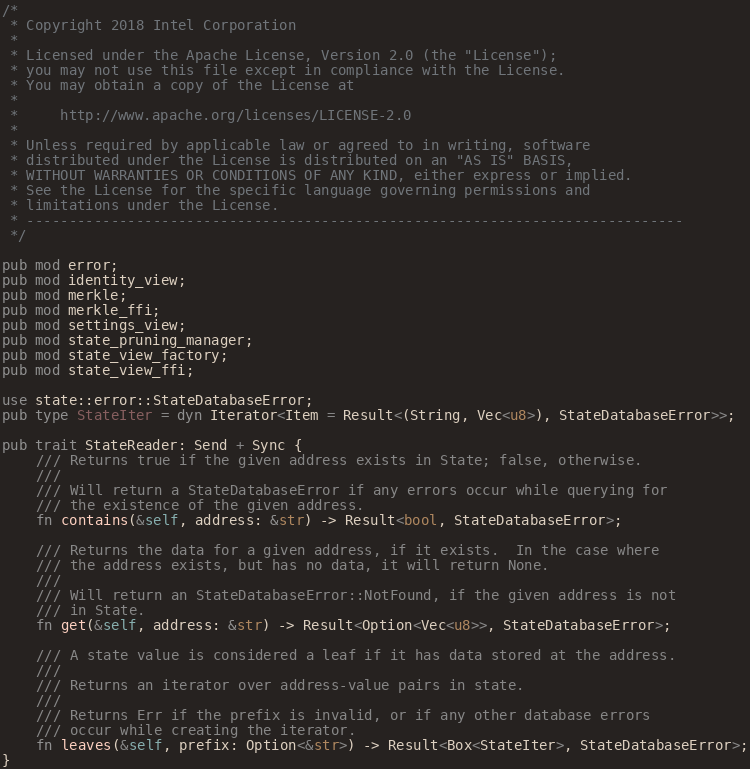Convert code to text. <code><loc_0><loc_0><loc_500><loc_500><_Rust_>/*
 * Copyright 2018 Intel Corporation
 *
 * Licensed under the Apache License, Version 2.0 (the "License");
 * you may not use this file except in compliance with the License.
 * You may obtain a copy of the License at
 *
 *     http://www.apache.org/licenses/LICENSE-2.0
 *
 * Unless required by applicable law or agreed to in writing, software
 * distributed under the License is distributed on an "AS IS" BASIS,
 * WITHOUT WARRANTIES OR CONDITIONS OF ANY KIND, either express or implied.
 * See the License for the specific language governing permissions and
 * limitations under the License.
 * ------------------------------------------------------------------------------
 */

pub mod error;
pub mod identity_view;
pub mod merkle;
pub mod merkle_ffi;
pub mod settings_view;
pub mod state_pruning_manager;
pub mod state_view_factory;
pub mod state_view_ffi;

use state::error::StateDatabaseError;
pub type StateIter = dyn Iterator<Item = Result<(String, Vec<u8>), StateDatabaseError>>;

pub trait StateReader: Send + Sync {
    /// Returns true if the given address exists in State; false, otherwise.
    ///
    /// Will return a StateDatabaseError if any errors occur while querying for
    /// the existence of the given address.
    fn contains(&self, address: &str) -> Result<bool, StateDatabaseError>;

    /// Returns the data for a given address, if it exists.  In the case where
    /// the address exists, but has no data, it will return None.
    ///
    /// Will return an StateDatabaseError::NotFound, if the given address is not
    /// in State.
    fn get(&self, address: &str) -> Result<Option<Vec<u8>>, StateDatabaseError>;

    /// A state value is considered a leaf if it has data stored at the address.
    ///
    /// Returns an iterator over address-value pairs in state.
    ///
    /// Returns Err if the prefix is invalid, or if any other database errors
    /// occur while creating the iterator.
    fn leaves(&self, prefix: Option<&str>) -> Result<Box<StateIter>, StateDatabaseError>;
}
</code> 